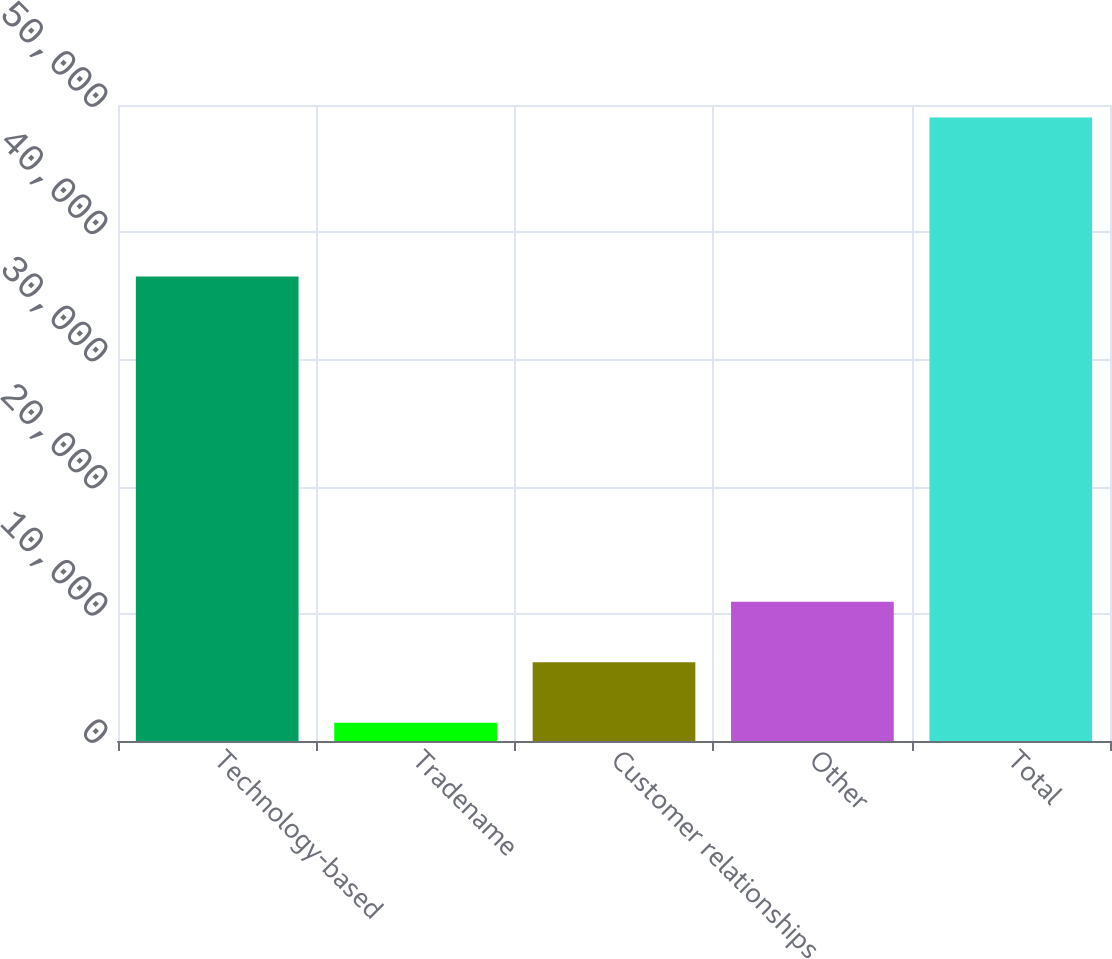Convert chart. <chart><loc_0><loc_0><loc_500><loc_500><bar_chart><fcel>Technology-based<fcel>Tradename<fcel>Customer relationships<fcel>Other<fcel>Total<nl><fcel>36516<fcel>1438<fcel>6195.9<fcel>10953.8<fcel>49017<nl></chart> 